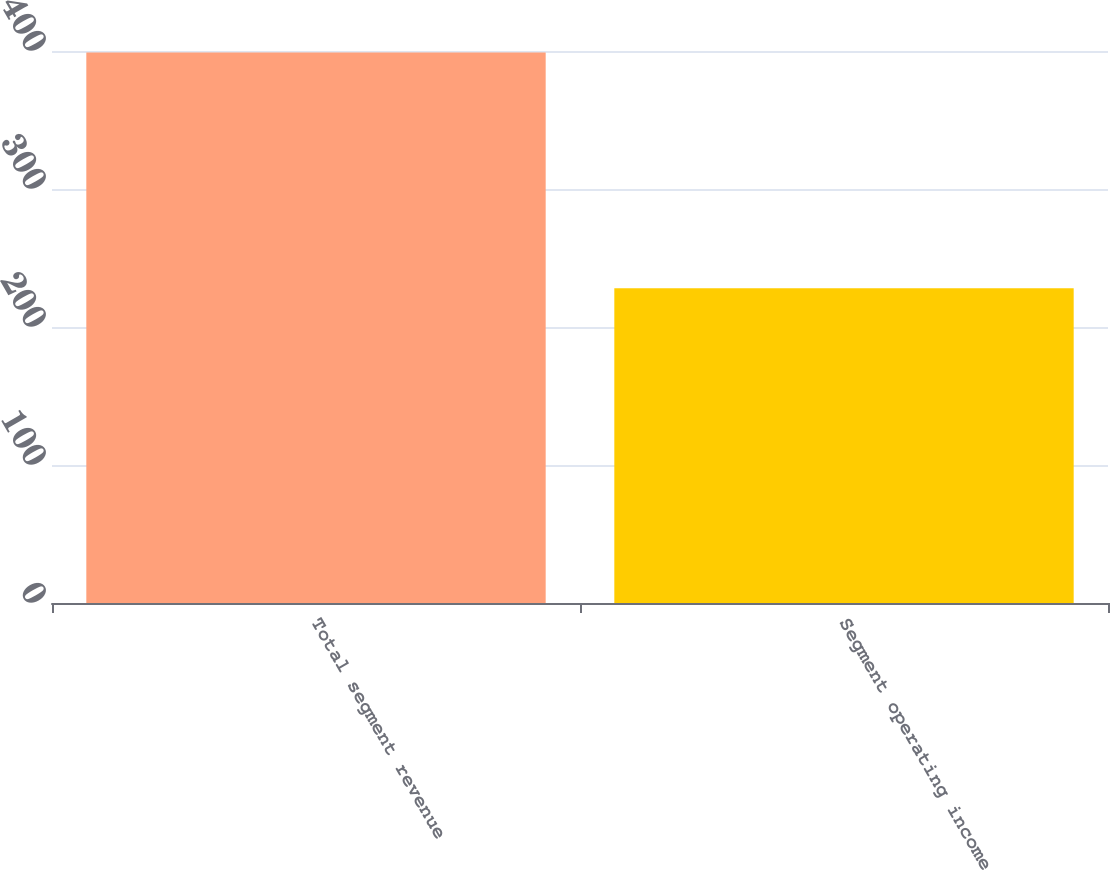Convert chart to OTSL. <chart><loc_0><loc_0><loc_500><loc_500><bar_chart><fcel>Total segment revenue<fcel>Segment operating income<nl><fcel>399<fcel>228<nl></chart> 